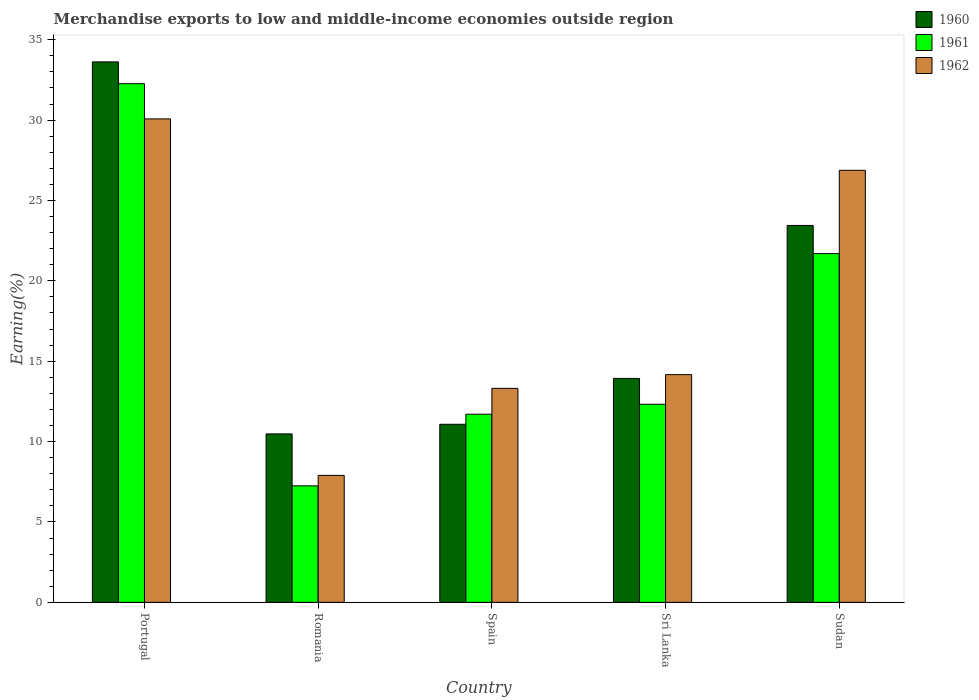How many different coloured bars are there?
Offer a very short reply. 3. How many groups of bars are there?
Your answer should be compact. 5. Are the number of bars per tick equal to the number of legend labels?
Make the answer very short. Yes. How many bars are there on the 5th tick from the left?
Your answer should be compact. 3. What is the label of the 2nd group of bars from the left?
Make the answer very short. Romania. What is the percentage of amount earned from merchandise exports in 1962 in Sudan?
Keep it short and to the point. 26.88. Across all countries, what is the maximum percentage of amount earned from merchandise exports in 1962?
Offer a terse response. 30.07. Across all countries, what is the minimum percentage of amount earned from merchandise exports in 1961?
Your answer should be very brief. 7.25. In which country was the percentage of amount earned from merchandise exports in 1961 maximum?
Ensure brevity in your answer.  Portugal. In which country was the percentage of amount earned from merchandise exports in 1962 minimum?
Offer a very short reply. Romania. What is the total percentage of amount earned from merchandise exports in 1960 in the graph?
Offer a very short reply. 92.55. What is the difference between the percentage of amount earned from merchandise exports in 1961 in Sri Lanka and that in Sudan?
Give a very brief answer. -9.37. What is the difference between the percentage of amount earned from merchandise exports in 1960 in Romania and the percentage of amount earned from merchandise exports in 1962 in Portugal?
Give a very brief answer. -19.6. What is the average percentage of amount earned from merchandise exports in 1961 per country?
Make the answer very short. 17.05. What is the difference between the percentage of amount earned from merchandise exports of/in 1960 and percentage of amount earned from merchandise exports of/in 1961 in Sri Lanka?
Your answer should be compact. 1.61. In how many countries, is the percentage of amount earned from merchandise exports in 1961 greater than 28 %?
Make the answer very short. 1. What is the ratio of the percentage of amount earned from merchandise exports in 1960 in Romania to that in Spain?
Your response must be concise. 0.95. Is the percentage of amount earned from merchandise exports in 1961 in Romania less than that in Sri Lanka?
Your response must be concise. Yes. Is the difference between the percentage of amount earned from merchandise exports in 1960 in Romania and Sri Lanka greater than the difference between the percentage of amount earned from merchandise exports in 1961 in Romania and Sri Lanka?
Your answer should be compact. Yes. What is the difference between the highest and the second highest percentage of amount earned from merchandise exports in 1962?
Your answer should be compact. -3.2. What is the difference between the highest and the lowest percentage of amount earned from merchandise exports in 1960?
Your answer should be compact. 23.14. Is the sum of the percentage of amount earned from merchandise exports in 1960 in Portugal and Spain greater than the maximum percentage of amount earned from merchandise exports in 1962 across all countries?
Your answer should be very brief. Yes. Is it the case that in every country, the sum of the percentage of amount earned from merchandise exports in 1961 and percentage of amount earned from merchandise exports in 1962 is greater than the percentage of amount earned from merchandise exports in 1960?
Offer a very short reply. Yes. How many bars are there?
Provide a succinct answer. 15. How many countries are there in the graph?
Offer a very short reply. 5. Are the values on the major ticks of Y-axis written in scientific E-notation?
Ensure brevity in your answer.  No. Does the graph contain any zero values?
Your answer should be very brief. No. Does the graph contain grids?
Your response must be concise. No. Where does the legend appear in the graph?
Your response must be concise. Top right. How are the legend labels stacked?
Your response must be concise. Vertical. What is the title of the graph?
Make the answer very short. Merchandise exports to low and middle-income economies outside region. What is the label or title of the Y-axis?
Provide a succinct answer. Earning(%). What is the Earning(%) of 1960 in Portugal?
Give a very brief answer. 33.62. What is the Earning(%) of 1961 in Portugal?
Provide a short and direct response. 32.26. What is the Earning(%) of 1962 in Portugal?
Offer a terse response. 30.07. What is the Earning(%) of 1960 in Romania?
Ensure brevity in your answer.  10.48. What is the Earning(%) in 1961 in Romania?
Your answer should be compact. 7.25. What is the Earning(%) in 1962 in Romania?
Your answer should be compact. 7.9. What is the Earning(%) of 1960 in Spain?
Your answer should be very brief. 11.08. What is the Earning(%) in 1961 in Spain?
Ensure brevity in your answer.  11.7. What is the Earning(%) in 1962 in Spain?
Make the answer very short. 13.31. What is the Earning(%) in 1960 in Sri Lanka?
Keep it short and to the point. 13.93. What is the Earning(%) of 1961 in Sri Lanka?
Provide a short and direct response. 12.32. What is the Earning(%) of 1962 in Sri Lanka?
Make the answer very short. 14.17. What is the Earning(%) of 1960 in Sudan?
Your answer should be compact. 23.45. What is the Earning(%) in 1961 in Sudan?
Your answer should be very brief. 21.69. What is the Earning(%) of 1962 in Sudan?
Provide a short and direct response. 26.88. Across all countries, what is the maximum Earning(%) of 1960?
Offer a terse response. 33.62. Across all countries, what is the maximum Earning(%) of 1961?
Your response must be concise. 32.26. Across all countries, what is the maximum Earning(%) in 1962?
Make the answer very short. 30.07. Across all countries, what is the minimum Earning(%) of 1960?
Your answer should be compact. 10.48. Across all countries, what is the minimum Earning(%) of 1961?
Provide a succinct answer. 7.25. Across all countries, what is the minimum Earning(%) in 1962?
Give a very brief answer. 7.9. What is the total Earning(%) of 1960 in the graph?
Offer a terse response. 92.55. What is the total Earning(%) of 1961 in the graph?
Give a very brief answer. 85.23. What is the total Earning(%) of 1962 in the graph?
Keep it short and to the point. 92.33. What is the difference between the Earning(%) of 1960 in Portugal and that in Romania?
Offer a terse response. 23.14. What is the difference between the Earning(%) in 1961 in Portugal and that in Romania?
Give a very brief answer. 25.02. What is the difference between the Earning(%) in 1962 in Portugal and that in Romania?
Offer a very short reply. 22.18. What is the difference between the Earning(%) of 1960 in Portugal and that in Spain?
Keep it short and to the point. 22.54. What is the difference between the Earning(%) of 1961 in Portugal and that in Spain?
Provide a short and direct response. 20.56. What is the difference between the Earning(%) in 1962 in Portugal and that in Spain?
Keep it short and to the point. 16.76. What is the difference between the Earning(%) in 1960 in Portugal and that in Sri Lanka?
Your answer should be very brief. 19.69. What is the difference between the Earning(%) of 1961 in Portugal and that in Sri Lanka?
Your response must be concise. 19.94. What is the difference between the Earning(%) of 1962 in Portugal and that in Sri Lanka?
Give a very brief answer. 15.91. What is the difference between the Earning(%) in 1960 in Portugal and that in Sudan?
Your answer should be very brief. 10.17. What is the difference between the Earning(%) in 1961 in Portugal and that in Sudan?
Your answer should be very brief. 10.57. What is the difference between the Earning(%) of 1962 in Portugal and that in Sudan?
Your answer should be compact. 3.2. What is the difference between the Earning(%) in 1960 in Romania and that in Spain?
Your response must be concise. -0.6. What is the difference between the Earning(%) of 1961 in Romania and that in Spain?
Give a very brief answer. -4.46. What is the difference between the Earning(%) of 1962 in Romania and that in Spain?
Make the answer very short. -5.41. What is the difference between the Earning(%) of 1960 in Romania and that in Sri Lanka?
Provide a succinct answer. -3.45. What is the difference between the Earning(%) in 1961 in Romania and that in Sri Lanka?
Offer a very short reply. -5.08. What is the difference between the Earning(%) of 1962 in Romania and that in Sri Lanka?
Offer a terse response. -6.27. What is the difference between the Earning(%) in 1960 in Romania and that in Sudan?
Make the answer very short. -12.97. What is the difference between the Earning(%) of 1961 in Romania and that in Sudan?
Provide a short and direct response. -14.45. What is the difference between the Earning(%) of 1962 in Romania and that in Sudan?
Provide a succinct answer. -18.98. What is the difference between the Earning(%) in 1960 in Spain and that in Sri Lanka?
Offer a very short reply. -2.85. What is the difference between the Earning(%) in 1961 in Spain and that in Sri Lanka?
Your response must be concise. -0.62. What is the difference between the Earning(%) in 1962 in Spain and that in Sri Lanka?
Keep it short and to the point. -0.85. What is the difference between the Earning(%) of 1960 in Spain and that in Sudan?
Your answer should be very brief. -12.37. What is the difference between the Earning(%) in 1961 in Spain and that in Sudan?
Provide a succinct answer. -9.99. What is the difference between the Earning(%) in 1962 in Spain and that in Sudan?
Give a very brief answer. -13.56. What is the difference between the Earning(%) of 1960 in Sri Lanka and that in Sudan?
Offer a very short reply. -9.52. What is the difference between the Earning(%) of 1961 in Sri Lanka and that in Sudan?
Offer a terse response. -9.37. What is the difference between the Earning(%) in 1962 in Sri Lanka and that in Sudan?
Give a very brief answer. -12.71. What is the difference between the Earning(%) of 1960 in Portugal and the Earning(%) of 1961 in Romania?
Your answer should be very brief. 26.37. What is the difference between the Earning(%) in 1960 in Portugal and the Earning(%) in 1962 in Romania?
Your response must be concise. 25.72. What is the difference between the Earning(%) of 1961 in Portugal and the Earning(%) of 1962 in Romania?
Your answer should be very brief. 24.37. What is the difference between the Earning(%) in 1960 in Portugal and the Earning(%) in 1961 in Spain?
Make the answer very short. 21.92. What is the difference between the Earning(%) of 1960 in Portugal and the Earning(%) of 1962 in Spain?
Offer a terse response. 20.31. What is the difference between the Earning(%) of 1961 in Portugal and the Earning(%) of 1962 in Spain?
Keep it short and to the point. 18.95. What is the difference between the Earning(%) of 1960 in Portugal and the Earning(%) of 1961 in Sri Lanka?
Offer a very short reply. 21.3. What is the difference between the Earning(%) in 1960 in Portugal and the Earning(%) in 1962 in Sri Lanka?
Give a very brief answer. 19.45. What is the difference between the Earning(%) of 1961 in Portugal and the Earning(%) of 1962 in Sri Lanka?
Your response must be concise. 18.1. What is the difference between the Earning(%) in 1960 in Portugal and the Earning(%) in 1961 in Sudan?
Offer a very short reply. 11.93. What is the difference between the Earning(%) in 1960 in Portugal and the Earning(%) in 1962 in Sudan?
Keep it short and to the point. 6.74. What is the difference between the Earning(%) in 1961 in Portugal and the Earning(%) in 1962 in Sudan?
Your answer should be compact. 5.39. What is the difference between the Earning(%) of 1960 in Romania and the Earning(%) of 1961 in Spain?
Your response must be concise. -1.23. What is the difference between the Earning(%) of 1960 in Romania and the Earning(%) of 1962 in Spain?
Your response must be concise. -2.83. What is the difference between the Earning(%) of 1961 in Romania and the Earning(%) of 1962 in Spain?
Your answer should be compact. -6.07. What is the difference between the Earning(%) in 1960 in Romania and the Earning(%) in 1961 in Sri Lanka?
Provide a succinct answer. -1.84. What is the difference between the Earning(%) of 1960 in Romania and the Earning(%) of 1962 in Sri Lanka?
Offer a very short reply. -3.69. What is the difference between the Earning(%) in 1961 in Romania and the Earning(%) in 1962 in Sri Lanka?
Offer a very short reply. -6.92. What is the difference between the Earning(%) in 1960 in Romania and the Earning(%) in 1961 in Sudan?
Give a very brief answer. -11.21. What is the difference between the Earning(%) of 1960 in Romania and the Earning(%) of 1962 in Sudan?
Offer a terse response. -16.4. What is the difference between the Earning(%) in 1961 in Romania and the Earning(%) in 1962 in Sudan?
Keep it short and to the point. -19.63. What is the difference between the Earning(%) of 1960 in Spain and the Earning(%) of 1961 in Sri Lanka?
Your answer should be very brief. -1.25. What is the difference between the Earning(%) of 1960 in Spain and the Earning(%) of 1962 in Sri Lanka?
Your response must be concise. -3.09. What is the difference between the Earning(%) of 1961 in Spain and the Earning(%) of 1962 in Sri Lanka?
Give a very brief answer. -2.46. What is the difference between the Earning(%) in 1960 in Spain and the Earning(%) in 1961 in Sudan?
Your answer should be very brief. -10.62. What is the difference between the Earning(%) of 1960 in Spain and the Earning(%) of 1962 in Sudan?
Give a very brief answer. -15.8. What is the difference between the Earning(%) of 1961 in Spain and the Earning(%) of 1962 in Sudan?
Your answer should be very brief. -15.17. What is the difference between the Earning(%) of 1960 in Sri Lanka and the Earning(%) of 1961 in Sudan?
Your response must be concise. -7.76. What is the difference between the Earning(%) in 1960 in Sri Lanka and the Earning(%) in 1962 in Sudan?
Offer a terse response. -12.95. What is the difference between the Earning(%) in 1961 in Sri Lanka and the Earning(%) in 1962 in Sudan?
Give a very brief answer. -14.55. What is the average Earning(%) of 1960 per country?
Provide a short and direct response. 18.51. What is the average Earning(%) in 1961 per country?
Your response must be concise. 17.05. What is the average Earning(%) of 1962 per country?
Make the answer very short. 18.47. What is the difference between the Earning(%) in 1960 and Earning(%) in 1961 in Portugal?
Offer a very short reply. 1.36. What is the difference between the Earning(%) of 1960 and Earning(%) of 1962 in Portugal?
Provide a succinct answer. 3.54. What is the difference between the Earning(%) in 1961 and Earning(%) in 1962 in Portugal?
Provide a short and direct response. 2.19. What is the difference between the Earning(%) in 1960 and Earning(%) in 1961 in Romania?
Give a very brief answer. 3.23. What is the difference between the Earning(%) in 1960 and Earning(%) in 1962 in Romania?
Ensure brevity in your answer.  2.58. What is the difference between the Earning(%) in 1961 and Earning(%) in 1962 in Romania?
Your answer should be very brief. -0.65. What is the difference between the Earning(%) in 1960 and Earning(%) in 1961 in Spain?
Offer a very short reply. -0.63. What is the difference between the Earning(%) in 1960 and Earning(%) in 1962 in Spain?
Your answer should be very brief. -2.24. What is the difference between the Earning(%) of 1961 and Earning(%) of 1962 in Spain?
Your answer should be compact. -1.61. What is the difference between the Earning(%) in 1960 and Earning(%) in 1961 in Sri Lanka?
Make the answer very short. 1.61. What is the difference between the Earning(%) of 1960 and Earning(%) of 1962 in Sri Lanka?
Keep it short and to the point. -0.24. What is the difference between the Earning(%) in 1961 and Earning(%) in 1962 in Sri Lanka?
Your response must be concise. -1.84. What is the difference between the Earning(%) in 1960 and Earning(%) in 1961 in Sudan?
Offer a terse response. 1.75. What is the difference between the Earning(%) of 1960 and Earning(%) of 1962 in Sudan?
Make the answer very short. -3.43. What is the difference between the Earning(%) of 1961 and Earning(%) of 1962 in Sudan?
Offer a very short reply. -5.18. What is the ratio of the Earning(%) of 1960 in Portugal to that in Romania?
Your answer should be compact. 3.21. What is the ratio of the Earning(%) of 1961 in Portugal to that in Romania?
Keep it short and to the point. 4.45. What is the ratio of the Earning(%) of 1962 in Portugal to that in Romania?
Keep it short and to the point. 3.81. What is the ratio of the Earning(%) of 1960 in Portugal to that in Spain?
Give a very brief answer. 3.03. What is the ratio of the Earning(%) of 1961 in Portugal to that in Spain?
Make the answer very short. 2.76. What is the ratio of the Earning(%) of 1962 in Portugal to that in Spain?
Keep it short and to the point. 2.26. What is the ratio of the Earning(%) of 1960 in Portugal to that in Sri Lanka?
Your response must be concise. 2.41. What is the ratio of the Earning(%) of 1961 in Portugal to that in Sri Lanka?
Your answer should be compact. 2.62. What is the ratio of the Earning(%) in 1962 in Portugal to that in Sri Lanka?
Ensure brevity in your answer.  2.12. What is the ratio of the Earning(%) of 1960 in Portugal to that in Sudan?
Your response must be concise. 1.43. What is the ratio of the Earning(%) in 1961 in Portugal to that in Sudan?
Your answer should be very brief. 1.49. What is the ratio of the Earning(%) in 1962 in Portugal to that in Sudan?
Your answer should be very brief. 1.12. What is the ratio of the Earning(%) in 1960 in Romania to that in Spain?
Make the answer very short. 0.95. What is the ratio of the Earning(%) of 1961 in Romania to that in Spain?
Offer a very short reply. 0.62. What is the ratio of the Earning(%) of 1962 in Romania to that in Spain?
Ensure brevity in your answer.  0.59. What is the ratio of the Earning(%) in 1960 in Romania to that in Sri Lanka?
Ensure brevity in your answer.  0.75. What is the ratio of the Earning(%) of 1961 in Romania to that in Sri Lanka?
Your answer should be compact. 0.59. What is the ratio of the Earning(%) of 1962 in Romania to that in Sri Lanka?
Give a very brief answer. 0.56. What is the ratio of the Earning(%) of 1960 in Romania to that in Sudan?
Make the answer very short. 0.45. What is the ratio of the Earning(%) of 1961 in Romania to that in Sudan?
Offer a very short reply. 0.33. What is the ratio of the Earning(%) in 1962 in Romania to that in Sudan?
Keep it short and to the point. 0.29. What is the ratio of the Earning(%) in 1960 in Spain to that in Sri Lanka?
Your answer should be very brief. 0.8. What is the ratio of the Earning(%) of 1961 in Spain to that in Sri Lanka?
Your answer should be very brief. 0.95. What is the ratio of the Earning(%) in 1962 in Spain to that in Sri Lanka?
Your response must be concise. 0.94. What is the ratio of the Earning(%) in 1960 in Spain to that in Sudan?
Provide a short and direct response. 0.47. What is the ratio of the Earning(%) of 1961 in Spain to that in Sudan?
Provide a short and direct response. 0.54. What is the ratio of the Earning(%) in 1962 in Spain to that in Sudan?
Offer a very short reply. 0.5. What is the ratio of the Earning(%) of 1960 in Sri Lanka to that in Sudan?
Make the answer very short. 0.59. What is the ratio of the Earning(%) of 1961 in Sri Lanka to that in Sudan?
Make the answer very short. 0.57. What is the ratio of the Earning(%) of 1962 in Sri Lanka to that in Sudan?
Your answer should be very brief. 0.53. What is the difference between the highest and the second highest Earning(%) in 1960?
Provide a succinct answer. 10.17. What is the difference between the highest and the second highest Earning(%) in 1961?
Your answer should be compact. 10.57. What is the difference between the highest and the second highest Earning(%) in 1962?
Offer a very short reply. 3.2. What is the difference between the highest and the lowest Earning(%) in 1960?
Provide a succinct answer. 23.14. What is the difference between the highest and the lowest Earning(%) in 1961?
Your response must be concise. 25.02. What is the difference between the highest and the lowest Earning(%) of 1962?
Keep it short and to the point. 22.18. 